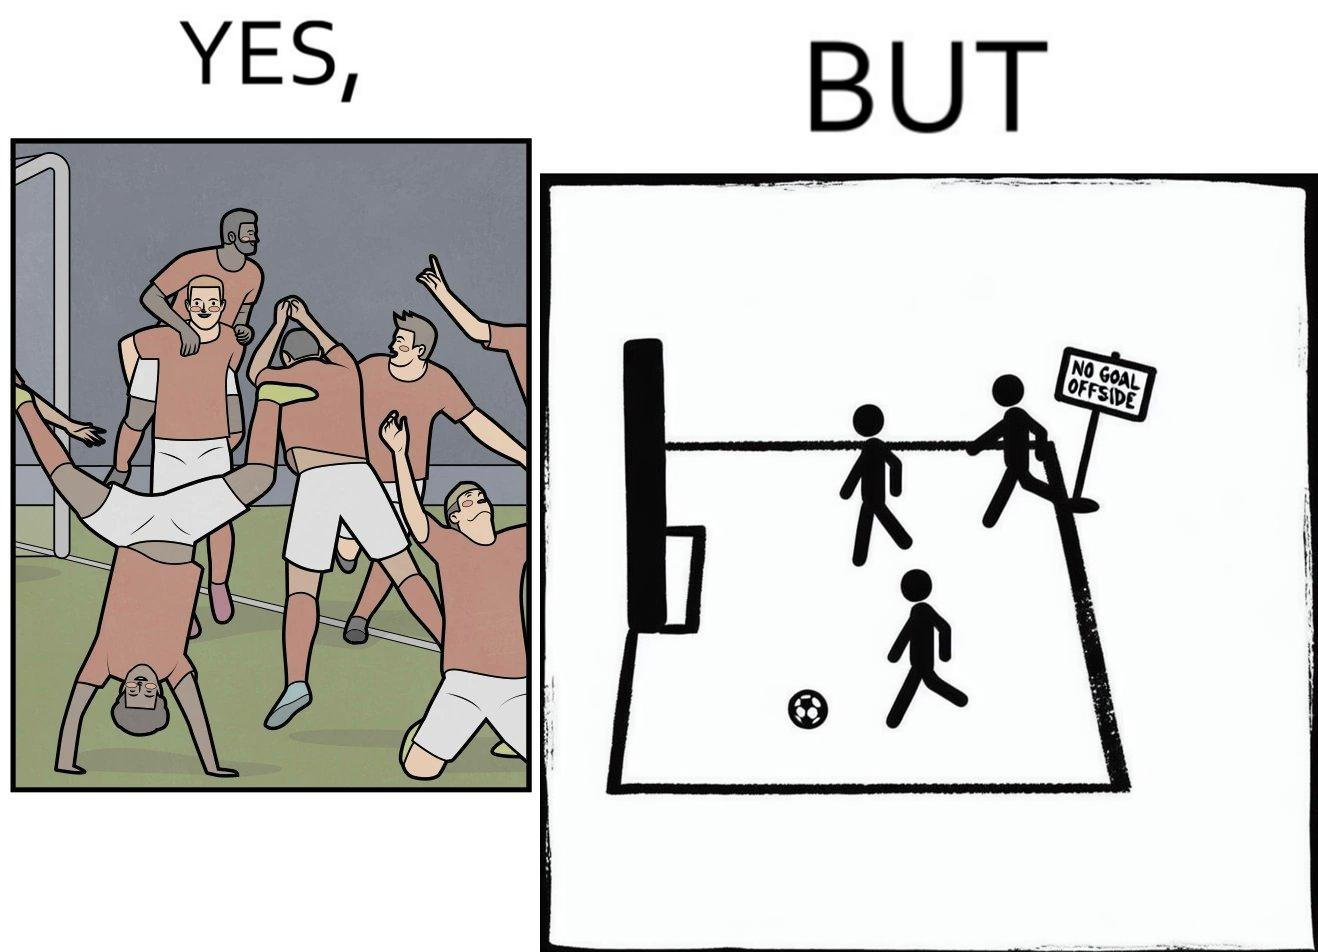Would you classify this image as satirical? Yes, this image is satirical. 